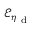Convert formula to latex. <formula><loc_0><loc_0><loc_500><loc_500>\mathcal { E } _ { \eta _ { d } }</formula> 